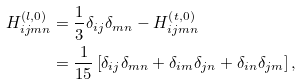<formula> <loc_0><loc_0><loc_500><loc_500>H _ { i j m n } ^ { \left ( l , 0 \right ) } & = \frac { 1 } { 3 } \delta _ { i j } \delta _ { m n } - H _ { i j m n } ^ { \left ( t , 0 \right ) } \\ & = \frac { 1 } { 1 5 } \left [ \delta _ { i j } \delta _ { m n } + \delta _ { i m } \delta _ { j n } + \delta _ { i n } \delta _ { j m } \right ] ,</formula> 